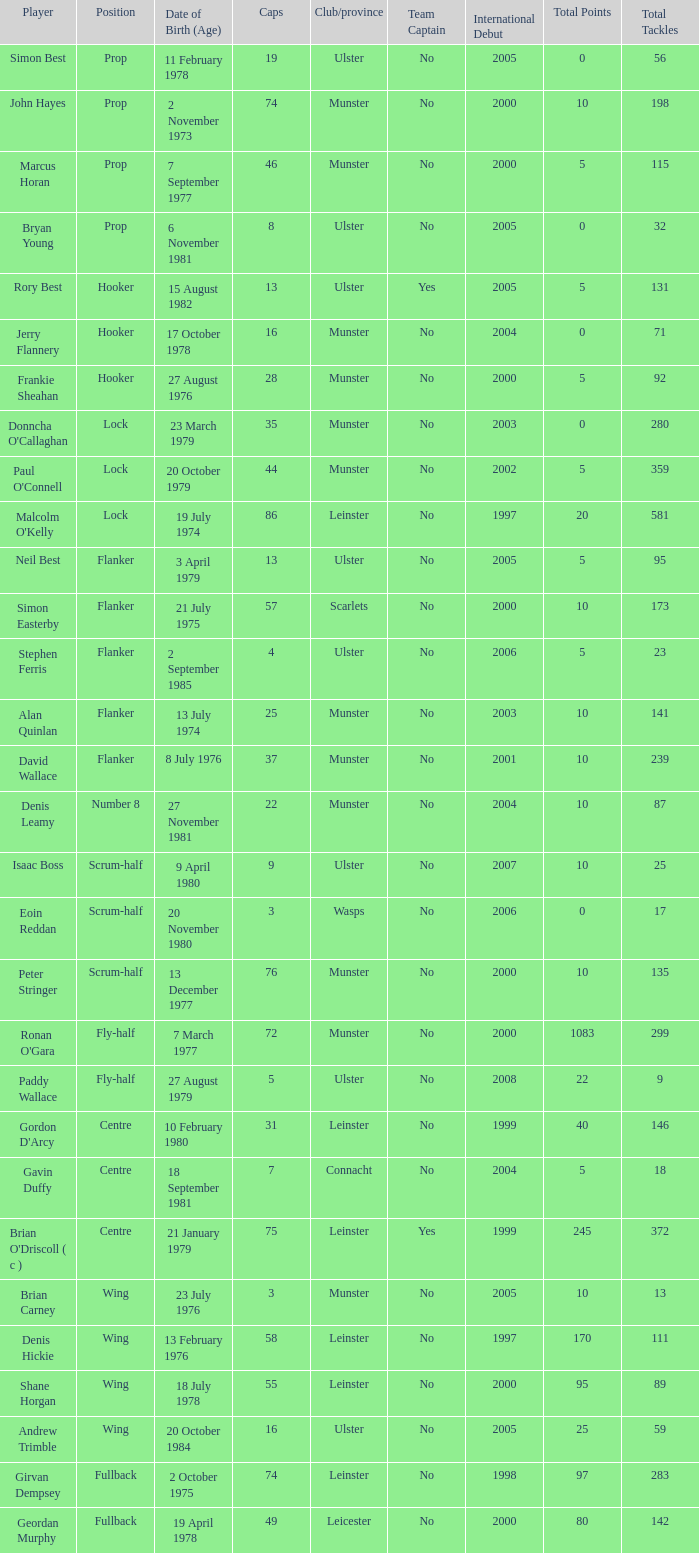Which player Munster from Munster is a fly-half? Ronan O'Gara. 